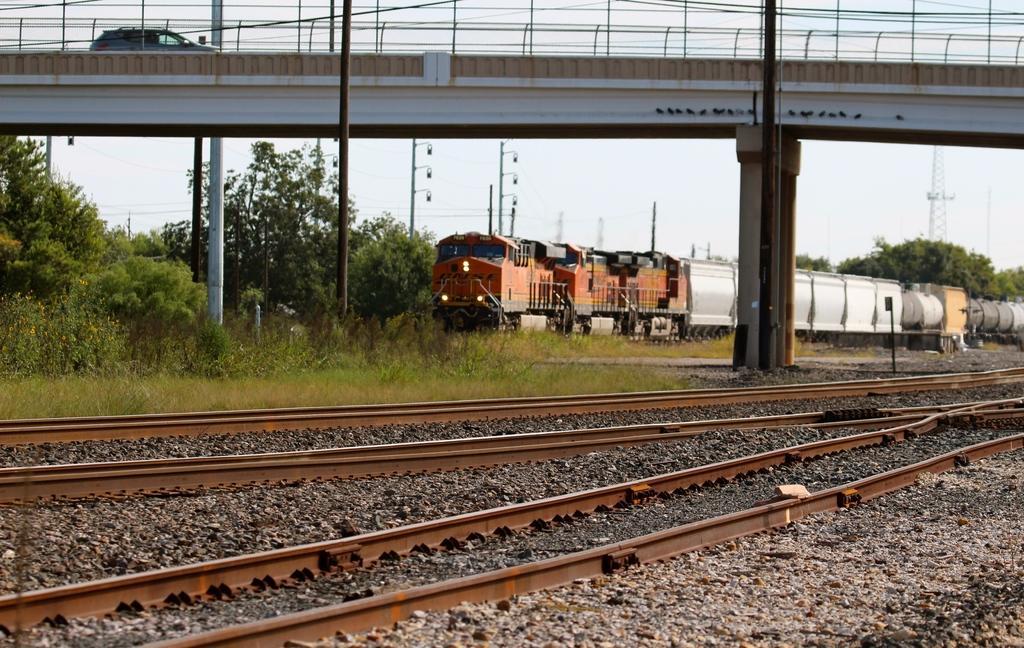Describe this image in one or two sentences. In this image there are train tracks, rocks, grass, bridge, poles, vehicle, tower, trees, train, sky and objects. Vehicle is on the bridge. 